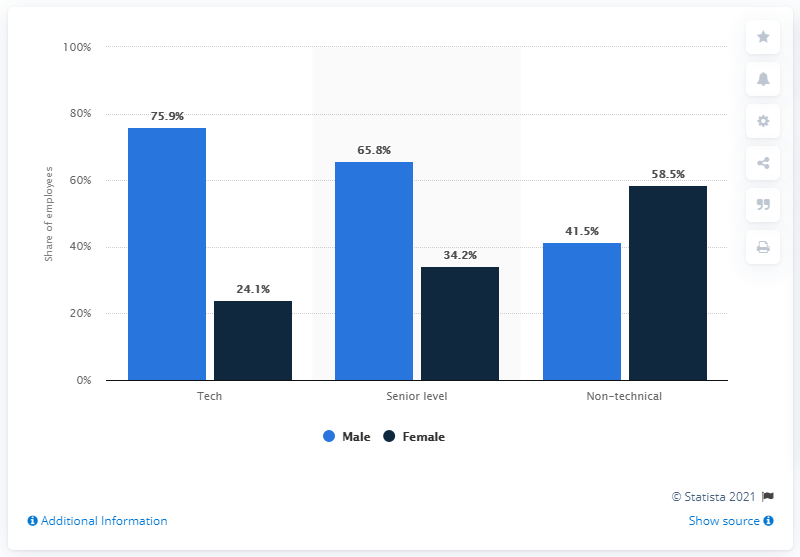Point out several critical features in this image. There are three categories of employees depicted in the graph. As of June 2020, only 34.2% of Facebook's global senior-level employees were female. The difference between the highest senior male employee and the lowest tech employee in terms of salary is 41.7%. 